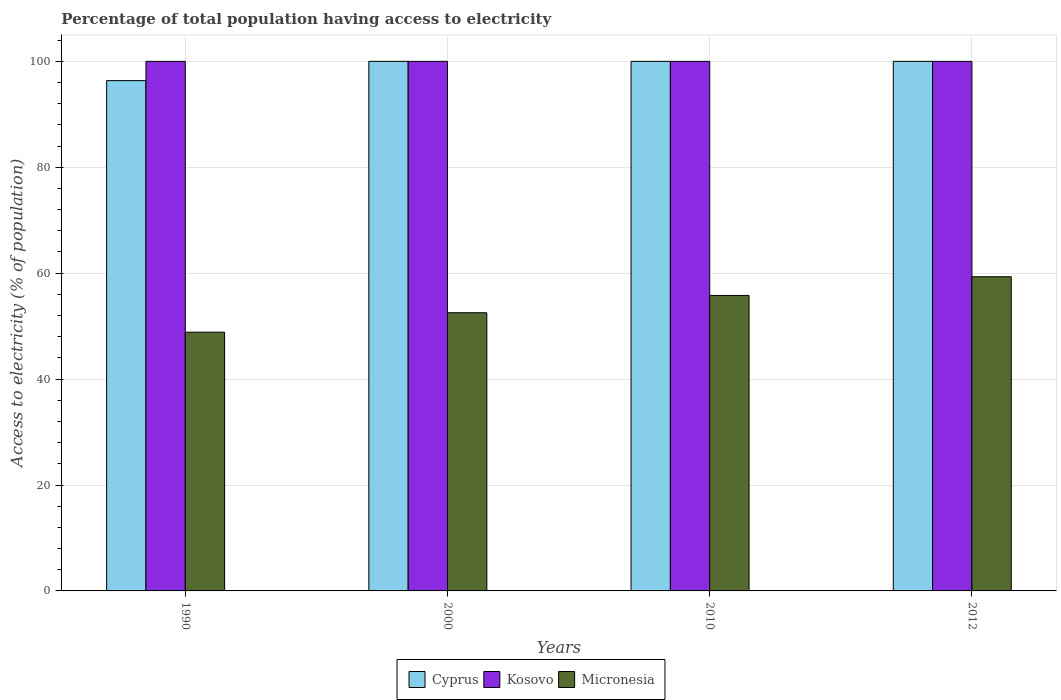Are the number of bars per tick equal to the number of legend labels?
Provide a succinct answer. Yes. Are the number of bars on each tick of the X-axis equal?
Offer a very short reply. Yes. How many bars are there on the 3rd tick from the left?
Provide a short and direct response. 3. How many bars are there on the 3rd tick from the right?
Provide a succinct answer. 3. What is the label of the 2nd group of bars from the left?
Give a very brief answer. 2000. Across all years, what is the maximum percentage of population that have access to electricity in Micronesia?
Offer a very short reply. 59.33. Across all years, what is the minimum percentage of population that have access to electricity in Cyprus?
Keep it short and to the point. 96.36. What is the total percentage of population that have access to electricity in Cyprus in the graph?
Offer a terse response. 396.36. What is the difference between the percentage of population that have access to electricity in Micronesia in 1990 and that in 2000?
Ensure brevity in your answer.  -3.67. What is the difference between the percentage of population that have access to electricity in Kosovo in 2000 and the percentage of population that have access to electricity in Micronesia in 2010?
Keep it short and to the point. 44.2. In the year 2010, what is the difference between the percentage of population that have access to electricity in Kosovo and percentage of population that have access to electricity in Micronesia?
Offer a very short reply. 44.2. What is the ratio of the percentage of population that have access to electricity in Cyprus in 1990 to that in 2012?
Offer a very short reply. 0.96. Is the difference between the percentage of population that have access to electricity in Kosovo in 2010 and 2012 greater than the difference between the percentage of population that have access to electricity in Micronesia in 2010 and 2012?
Provide a short and direct response. Yes. What is the difference between the highest and the second highest percentage of population that have access to electricity in Cyprus?
Make the answer very short. 0. What is the difference between the highest and the lowest percentage of population that have access to electricity in Micronesia?
Provide a short and direct response. 10.47. Is the sum of the percentage of population that have access to electricity in Cyprus in 1990 and 2000 greater than the maximum percentage of population that have access to electricity in Micronesia across all years?
Provide a succinct answer. Yes. What does the 1st bar from the left in 2010 represents?
Provide a succinct answer. Cyprus. What does the 3rd bar from the right in 2012 represents?
Give a very brief answer. Cyprus. How many years are there in the graph?
Offer a terse response. 4. What is the difference between two consecutive major ticks on the Y-axis?
Your answer should be compact. 20. Are the values on the major ticks of Y-axis written in scientific E-notation?
Ensure brevity in your answer.  No. Does the graph contain any zero values?
Offer a terse response. No. Does the graph contain grids?
Make the answer very short. Yes. How many legend labels are there?
Provide a short and direct response. 3. How are the legend labels stacked?
Offer a very short reply. Horizontal. What is the title of the graph?
Your response must be concise. Percentage of total population having access to electricity. What is the label or title of the Y-axis?
Your answer should be very brief. Access to electricity (% of population). What is the Access to electricity (% of population) in Cyprus in 1990?
Provide a succinct answer. 96.36. What is the Access to electricity (% of population) in Kosovo in 1990?
Your answer should be compact. 100. What is the Access to electricity (% of population) in Micronesia in 1990?
Provide a short and direct response. 48.86. What is the Access to electricity (% of population) in Cyprus in 2000?
Make the answer very short. 100. What is the Access to electricity (% of population) of Micronesia in 2000?
Provide a succinct answer. 52.53. What is the Access to electricity (% of population) in Kosovo in 2010?
Ensure brevity in your answer.  100. What is the Access to electricity (% of population) of Micronesia in 2010?
Offer a very short reply. 55.8. What is the Access to electricity (% of population) of Micronesia in 2012?
Ensure brevity in your answer.  59.33. Across all years, what is the maximum Access to electricity (% of population) in Micronesia?
Provide a short and direct response. 59.33. Across all years, what is the minimum Access to electricity (% of population) of Cyprus?
Make the answer very short. 96.36. Across all years, what is the minimum Access to electricity (% of population) in Kosovo?
Your response must be concise. 100. Across all years, what is the minimum Access to electricity (% of population) of Micronesia?
Your answer should be very brief. 48.86. What is the total Access to electricity (% of population) in Cyprus in the graph?
Ensure brevity in your answer.  396.36. What is the total Access to electricity (% of population) in Micronesia in the graph?
Your response must be concise. 216.52. What is the difference between the Access to electricity (% of population) of Cyprus in 1990 and that in 2000?
Keep it short and to the point. -3.64. What is the difference between the Access to electricity (% of population) of Micronesia in 1990 and that in 2000?
Offer a terse response. -3.67. What is the difference between the Access to electricity (% of population) in Cyprus in 1990 and that in 2010?
Give a very brief answer. -3.64. What is the difference between the Access to electricity (% of population) of Micronesia in 1990 and that in 2010?
Provide a short and direct response. -6.94. What is the difference between the Access to electricity (% of population) in Cyprus in 1990 and that in 2012?
Ensure brevity in your answer.  -3.64. What is the difference between the Access to electricity (% of population) in Kosovo in 1990 and that in 2012?
Your response must be concise. 0. What is the difference between the Access to electricity (% of population) of Micronesia in 1990 and that in 2012?
Keep it short and to the point. -10.47. What is the difference between the Access to electricity (% of population) in Cyprus in 2000 and that in 2010?
Offer a very short reply. 0. What is the difference between the Access to electricity (% of population) in Kosovo in 2000 and that in 2010?
Provide a short and direct response. 0. What is the difference between the Access to electricity (% of population) in Micronesia in 2000 and that in 2010?
Your answer should be very brief. -3.27. What is the difference between the Access to electricity (% of population) in Cyprus in 2000 and that in 2012?
Your answer should be compact. 0. What is the difference between the Access to electricity (% of population) in Kosovo in 2000 and that in 2012?
Offer a very short reply. 0. What is the difference between the Access to electricity (% of population) in Micronesia in 2000 and that in 2012?
Keep it short and to the point. -6.8. What is the difference between the Access to electricity (% of population) in Cyprus in 2010 and that in 2012?
Give a very brief answer. 0. What is the difference between the Access to electricity (% of population) of Kosovo in 2010 and that in 2012?
Your answer should be very brief. 0. What is the difference between the Access to electricity (% of population) of Micronesia in 2010 and that in 2012?
Ensure brevity in your answer.  -3.53. What is the difference between the Access to electricity (% of population) of Cyprus in 1990 and the Access to electricity (% of population) of Kosovo in 2000?
Make the answer very short. -3.64. What is the difference between the Access to electricity (% of population) of Cyprus in 1990 and the Access to electricity (% of population) of Micronesia in 2000?
Provide a short and direct response. 43.83. What is the difference between the Access to electricity (% of population) of Kosovo in 1990 and the Access to electricity (% of population) of Micronesia in 2000?
Your response must be concise. 47.47. What is the difference between the Access to electricity (% of population) in Cyprus in 1990 and the Access to electricity (% of population) in Kosovo in 2010?
Your answer should be very brief. -3.64. What is the difference between the Access to electricity (% of population) in Cyprus in 1990 and the Access to electricity (% of population) in Micronesia in 2010?
Ensure brevity in your answer.  40.56. What is the difference between the Access to electricity (% of population) of Kosovo in 1990 and the Access to electricity (% of population) of Micronesia in 2010?
Give a very brief answer. 44.2. What is the difference between the Access to electricity (% of population) in Cyprus in 1990 and the Access to electricity (% of population) in Kosovo in 2012?
Keep it short and to the point. -3.64. What is the difference between the Access to electricity (% of population) of Cyprus in 1990 and the Access to electricity (% of population) of Micronesia in 2012?
Your answer should be very brief. 37.03. What is the difference between the Access to electricity (% of population) in Kosovo in 1990 and the Access to electricity (% of population) in Micronesia in 2012?
Provide a succinct answer. 40.67. What is the difference between the Access to electricity (% of population) of Cyprus in 2000 and the Access to electricity (% of population) of Micronesia in 2010?
Your answer should be compact. 44.2. What is the difference between the Access to electricity (% of population) in Kosovo in 2000 and the Access to electricity (% of population) in Micronesia in 2010?
Offer a terse response. 44.2. What is the difference between the Access to electricity (% of population) in Cyprus in 2000 and the Access to electricity (% of population) in Micronesia in 2012?
Provide a short and direct response. 40.67. What is the difference between the Access to electricity (% of population) in Kosovo in 2000 and the Access to electricity (% of population) in Micronesia in 2012?
Your response must be concise. 40.67. What is the difference between the Access to electricity (% of population) of Cyprus in 2010 and the Access to electricity (% of population) of Kosovo in 2012?
Offer a very short reply. 0. What is the difference between the Access to electricity (% of population) of Cyprus in 2010 and the Access to electricity (% of population) of Micronesia in 2012?
Provide a short and direct response. 40.67. What is the difference between the Access to electricity (% of population) in Kosovo in 2010 and the Access to electricity (% of population) in Micronesia in 2012?
Your answer should be very brief. 40.67. What is the average Access to electricity (% of population) in Cyprus per year?
Offer a very short reply. 99.09. What is the average Access to electricity (% of population) of Micronesia per year?
Make the answer very short. 54.13. In the year 1990, what is the difference between the Access to electricity (% of population) in Cyprus and Access to electricity (% of population) in Kosovo?
Offer a very short reply. -3.64. In the year 1990, what is the difference between the Access to electricity (% of population) of Cyprus and Access to electricity (% of population) of Micronesia?
Offer a very short reply. 47.5. In the year 1990, what is the difference between the Access to electricity (% of population) in Kosovo and Access to electricity (% of population) in Micronesia?
Make the answer very short. 51.14. In the year 2000, what is the difference between the Access to electricity (% of population) of Cyprus and Access to electricity (% of population) of Micronesia?
Your answer should be compact. 47.47. In the year 2000, what is the difference between the Access to electricity (% of population) in Kosovo and Access to electricity (% of population) in Micronesia?
Offer a very short reply. 47.47. In the year 2010, what is the difference between the Access to electricity (% of population) in Cyprus and Access to electricity (% of population) in Kosovo?
Provide a short and direct response. 0. In the year 2010, what is the difference between the Access to electricity (% of population) in Cyprus and Access to electricity (% of population) in Micronesia?
Your response must be concise. 44.2. In the year 2010, what is the difference between the Access to electricity (% of population) of Kosovo and Access to electricity (% of population) of Micronesia?
Your response must be concise. 44.2. In the year 2012, what is the difference between the Access to electricity (% of population) in Cyprus and Access to electricity (% of population) in Kosovo?
Provide a succinct answer. 0. In the year 2012, what is the difference between the Access to electricity (% of population) in Cyprus and Access to electricity (% of population) in Micronesia?
Offer a very short reply. 40.67. In the year 2012, what is the difference between the Access to electricity (% of population) of Kosovo and Access to electricity (% of population) of Micronesia?
Your answer should be very brief. 40.67. What is the ratio of the Access to electricity (% of population) of Cyprus in 1990 to that in 2000?
Ensure brevity in your answer.  0.96. What is the ratio of the Access to electricity (% of population) of Kosovo in 1990 to that in 2000?
Provide a succinct answer. 1. What is the ratio of the Access to electricity (% of population) of Micronesia in 1990 to that in 2000?
Provide a succinct answer. 0.93. What is the ratio of the Access to electricity (% of population) of Cyprus in 1990 to that in 2010?
Your response must be concise. 0.96. What is the ratio of the Access to electricity (% of population) in Kosovo in 1990 to that in 2010?
Offer a very short reply. 1. What is the ratio of the Access to electricity (% of population) in Micronesia in 1990 to that in 2010?
Give a very brief answer. 0.88. What is the ratio of the Access to electricity (% of population) in Cyprus in 1990 to that in 2012?
Provide a succinct answer. 0.96. What is the ratio of the Access to electricity (% of population) of Micronesia in 1990 to that in 2012?
Your answer should be very brief. 0.82. What is the ratio of the Access to electricity (% of population) of Cyprus in 2000 to that in 2010?
Ensure brevity in your answer.  1. What is the ratio of the Access to electricity (% of population) in Kosovo in 2000 to that in 2010?
Give a very brief answer. 1. What is the ratio of the Access to electricity (% of population) of Micronesia in 2000 to that in 2010?
Your response must be concise. 0.94. What is the ratio of the Access to electricity (% of population) in Kosovo in 2000 to that in 2012?
Offer a terse response. 1. What is the ratio of the Access to electricity (% of population) in Micronesia in 2000 to that in 2012?
Keep it short and to the point. 0.89. What is the ratio of the Access to electricity (% of population) in Cyprus in 2010 to that in 2012?
Provide a succinct answer. 1. What is the ratio of the Access to electricity (% of population) of Kosovo in 2010 to that in 2012?
Keep it short and to the point. 1. What is the ratio of the Access to electricity (% of population) in Micronesia in 2010 to that in 2012?
Provide a short and direct response. 0.94. What is the difference between the highest and the second highest Access to electricity (% of population) in Micronesia?
Offer a very short reply. 3.53. What is the difference between the highest and the lowest Access to electricity (% of population) in Cyprus?
Offer a terse response. 3.64. What is the difference between the highest and the lowest Access to electricity (% of population) in Micronesia?
Make the answer very short. 10.47. 